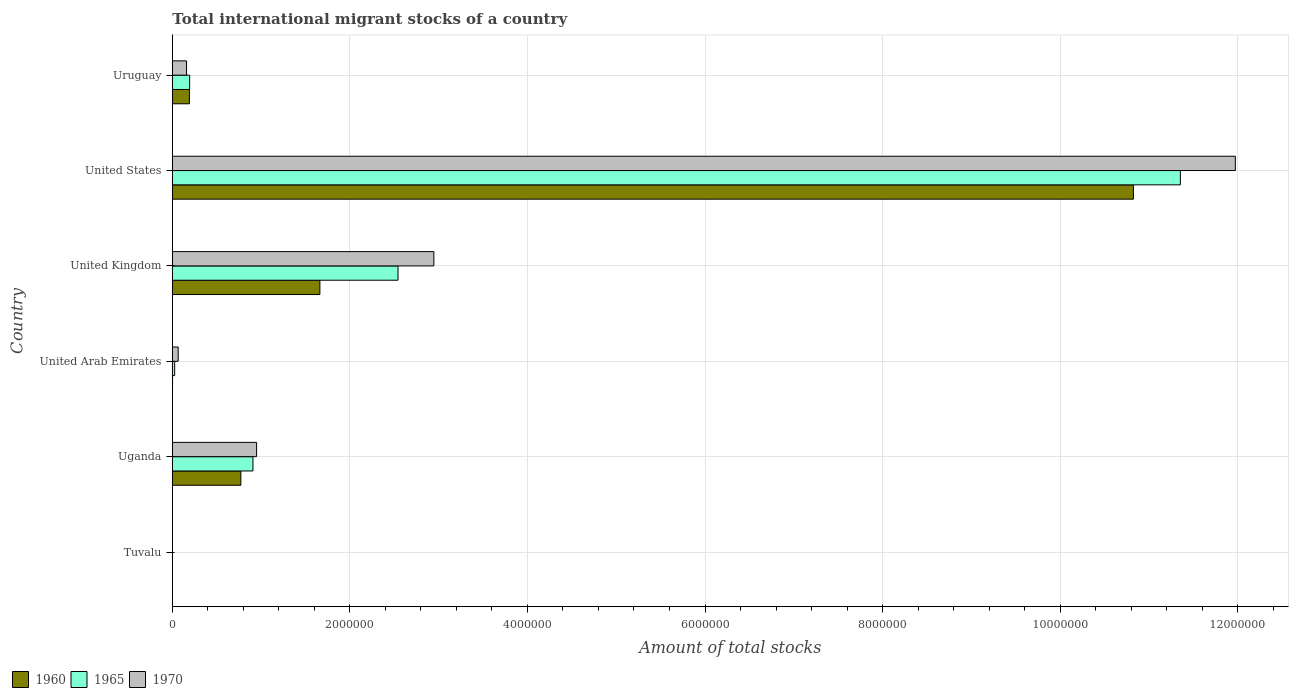How many different coloured bars are there?
Make the answer very short. 3. How many groups of bars are there?
Your answer should be compact. 6. Are the number of bars on each tick of the Y-axis equal?
Make the answer very short. Yes. In how many cases, is the number of bars for a given country not equal to the number of legend labels?
Provide a short and direct response. 0. What is the amount of total stocks in in 1970 in Uganda?
Give a very brief answer. 9.49e+05. Across all countries, what is the maximum amount of total stocks in in 1960?
Your answer should be very brief. 1.08e+07. Across all countries, what is the minimum amount of total stocks in in 1960?
Offer a terse response. 372. In which country was the amount of total stocks in in 1970 maximum?
Provide a short and direct response. United States. In which country was the amount of total stocks in in 1965 minimum?
Provide a short and direct response. Tuvalu. What is the total amount of total stocks in in 1970 in the graph?
Provide a short and direct response. 1.61e+07. What is the difference between the amount of total stocks in in 1960 in Tuvalu and that in United Arab Emirates?
Give a very brief answer. -1822. What is the difference between the amount of total stocks in in 1970 in United Kingdom and the amount of total stocks in in 1960 in United States?
Offer a terse response. -7.88e+06. What is the average amount of total stocks in in 1960 per country?
Offer a very short reply. 2.24e+06. What is the difference between the amount of total stocks in in 1970 and amount of total stocks in in 1960 in Uruguay?
Ensure brevity in your answer.  -3.22e+04. What is the ratio of the amount of total stocks in in 1965 in Uganda to that in United Kingdom?
Keep it short and to the point. 0.36. Is the difference between the amount of total stocks in in 1970 in United Arab Emirates and Uruguay greater than the difference between the amount of total stocks in in 1960 in United Arab Emirates and Uruguay?
Your answer should be compact. Yes. What is the difference between the highest and the second highest amount of total stocks in in 1960?
Provide a succinct answer. 9.16e+06. What is the difference between the highest and the lowest amount of total stocks in in 1965?
Your response must be concise. 1.14e+07. Is the sum of the amount of total stocks in in 1970 in Tuvalu and United Arab Emirates greater than the maximum amount of total stocks in in 1965 across all countries?
Provide a short and direct response. No. What does the 2nd bar from the top in United Kingdom represents?
Ensure brevity in your answer.  1965. What does the 3rd bar from the bottom in United States represents?
Provide a succinct answer. 1970. Is it the case that in every country, the sum of the amount of total stocks in in 1960 and amount of total stocks in in 1970 is greater than the amount of total stocks in in 1965?
Offer a terse response. Yes. How many bars are there?
Your answer should be compact. 18. Are the values on the major ticks of X-axis written in scientific E-notation?
Your answer should be compact. No. Does the graph contain any zero values?
Provide a succinct answer. No. Where does the legend appear in the graph?
Give a very brief answer. Bottom left. What is the title of the graph?
Ensure brevity in your answer.  Total international migrant stocks of a country. Does "1970" appear as one of the legend labels in the graph?
Give a very brief answer. Yes. What is the label or title of the X-axis?
Your answer should be very brief. Amount of total stocks. What is the Amount of total stocks in 1960 in Tuvalu?
Make the answer very short. 372. What is the Amount of total stocks in 1965 in Tuvalu?
Give a very brief answer. 363. What is the Amount of total stocks of 1970 in Tuvalu?
Ensure brevity in your answer.  355. What is the Amount of total stocks of 1960 in Uganda?
Make the answer very short. 7.72e+05. What is the Amount of total stocks of 1965 in Uganda?
Give a very brief answer. 9.08e+05. What is the Amount of total stocks of 1970 in Uganda?
Ensure brevity in your answer.  9.49e+05. What is the Amount of total stocks of 1960 in United Arab Emirates?
Your response must be concise. 2194. What is the Amount of total stocks of 1965 in United Arab Emirates?
Make the answer very short. 2.60e+04. What is the Amount of total stocks of 1970 in United Arab Emirates?
Provide a succinct answer. 6.58e+04. What is the Amount of total stocks of 1960 in United Kingdom?
Offer a very short reply. 1.66e+06. What is the Amount of total stocks of 1965 in United Kingdom?
Offer a terse response. 2.54e+06. What is the Amount of total stocks of 1970 in United Kingdom?
Ensure brevity in your answer.  2.95e+06. What is the Amount of total stocks in 1960 in United States?
Keep it short and to the point. 1.08e+07. What is the Amount of total stocks in 1965 in United States?
Give a very brief answer. 1.14e+07. What is the Amount of total stocks in 1970 in United States?
Your answer should be very brief. 1.20e+07. What is the Amount of total stocks in 1960 in Uruguay?
Keep it short and to the point. 1.92e+05. What is the Amount of total stocks of 1965 in Uruguay?
Keep it short and to the point. 1.95e+05. What is the Amount of total stocks of 1970 in Uruguay?
Your answer should be compact. 1.60e+05. Across all countries, what is the maximum Amount of total stocks in 1960?
Give a very brief answer. 1.08e+07. Across all countries, what is the maximum Amount of total stocks in 1965?
Offer a very short reply. 1.14e+07. Across all countries, what is the maximum Amount of total stocks of 1970?
Keep it short and to the point. 1.20e+07. Across all countries, what is the minimum Amount of total stocks of 1960?
Your response must be concise. 372. Across all countries, what is the minimum Amount of total stocks in 1965?
Keep it short and to the point. 363. Across all countries, what is the minimum Amount of total stocks of 1970?
Ensure brevity in your answer.  355. What is the total Amount of total stocks in 1960 in the graph?
Ensure brevity in your answer.  1.35e+07. What is the total Amount of total stocks in 1965 in the graph?
Keep it short and to the point. 1.50e+07. What is the total Amount of total stocks in 1970 in the graph?
Give a very brief answer. 1.61e+07. What is the difference between the Amount of total stocks of 1960 in Tuvalu and that in Uganda?
Your response must be concise. -7.71e+05. What is the difference between the Amount of total stocks of 1965 in Tuvalu and that in Uganda?
Offer a very short reply. -9.07e+05. What is the difference between the Amount of total stocks in 1970 in Tuvalu and that in Uganda?
Ensure brevity in your answer.  -9.49e+05. What is the difference between the Amount of total stocks in 1960 in Tuvalu and that in United Arab Emirates?
Offer a terse response. -1822. What is the difference between the Amount of total stocks in 1965 in Tuvalu and that in United Arab Emirates?
Provide a succinct answer. -2.56e+04. What is the difference between the Amount of total stocks in 1970 in Tuvalu and that in United Arab Emirates?
Offer a very short reply. -6.55e+04. What is the difference between the Amount of total stocks in 1960 in Tuvalu and that in United Kingdom?
Provide a short and direct response. -1.66e+06. What is the difference between the Amount of total stocks of 1965 in Tuvalu and that in United Kingdom?
Your response must be concise. -2.54e+06. What is the difference between the Amount of total stocks of 1970 in Tuvalu and that in United Kingdom?
Provide a short and direct response. -2.95e+06. What is the difference between the Amount of total stocks in 1960 in Tuvalu and that in United States?
Keep it short and to the point. -1.08e+07. What is the difference between the Amount of total stocks in 1965 in Tuvalu and that in United States?
Provide a short and direct response. -1.14e+07. What is the difference between the Amount of total stocks of 1970 in Tuvalu and that in United States?
Your answer should be compact. -1.20e+07. What is the difference between the Amount of total stocks of 1960 in Tuvalu and that in Uruguay?
Ensure brevity in your answer.  -1.92e+05. What is the difference between the Amount of total stocks in 1965 in Tuvalu and that in Uruguay?
Offer a very short reply. -1.95e+05. What is the difference between the Amount of total stocks of 1970 in Tuvalu and that in Uruguay?
Your answer should be very brief. -1.60e+05. What is the difference between the Amount of total stocks of 1960 in Uganda and that in United Arab Emirates?
Give a very brief answer. 7.70e+05. What is the difference between the Amount of total stocks of 1965 in Uganda and that in United Arab Emirates?
Your answer should be compact. 8.82e+05. What is the difference between the Amount of total stocks of 1970 in Uganda and that in United Arab Emirates?
Offer a terse response. 8.83e+05. What is the difference between the Amount of total stocks in 1960 in Uganda and that in United Kingdom?
Give a very brief answer. -8.90e+05. What is the difference between the Amount of total stocks in 1965 in Uganda and that in United Kingdom?
Ensure brevity in your answer.  -1.63e+06. What is the difference between the Amount of total stocks of 1970 in Uganda and that in United Kingdom?
Your response must be concise. -2.00e+06. What is the difference between the Amount of total stocks in 1960 in Uganda and that in United States?
Your answer should be very brief. -1.01e+07. What is the difference between the Amount of total stocks in 1965 in Uganda and that in United States?
Keep it short and to the point. -1.04e+07. What is the difference between the Amount of total stocks in 1970 in Uganda and that in United States?
Keep it short and to the point. -1.10e+07. What is the difference between the Amount of total stocks in 1960 in Uganda and that in Uruguay?
Provide a succinct answer. 5.80e+05. What is the difference between the Amount of total stocks of 1965 in Uganda and that in Uruguay?
Your answer should be compact. 7.13e+05. What is the difference between the Amount of total stocks of 1970 in Uganda and that in Uruguay?
Ensure brevity in your answer.  7.89e+05. What is the difference between the Amount of total stocks of 1960 in United Arab Emirates and that in United Kingdom?
Offer a terse response. -1.66e+06. What is the difference between the Amount of total stocks of 1965 in United Arab Emirates and that in United Kingdom?
Your response must be concise. -2.52e+06. What is the difference between the Amount of total stocks in 1970 in United Arab Emirates and that in United Kingdom?
Keep it short and to the point. -2.88e+06. What is the difference between the Amount of total stocks of 1960 in United Arab Emirates and that in United States?
Keep it short and to the point. -1.08e+07. What is the difference between the Amount of total stocks in 1965 in United Arab Emirates and that in United States?
Give a very brief answer. -1.13e+07. What is the difference between the Amount of total stocks of 1970 in United Arab Emirates and that in United States?
Your answer should be compact. -1.19e+07. What is the difference between the Amount of total stocks in 1960 in United Arab Emirates and that in Uruguay?
Give a very brief answer. -1.90e+05. What is the difference between the Amount of total stocks in 1965 in United Arab Emirates and that in Uruguay?
Your answer should be very brief. -1.69e+05. What is the difference between the Amount of total stocks of 1970 in United Arab Emirates and that in Uruguay?
Keep it short and to the point. -9.41e+04. What is the difference between the Amount of total stocks in 1960 in United Kingdom and that in United States?
Offer a very short reply. -9.16e+06. What is the difference between the Amount of total stocks in 1965 in United Kingdom and that in United States?
Your answer should be very brief. -8.81e+06. What is the difference between the Amount of total stocks in 1970 in United Kingdom and that in United States?
Provide a succinct answer. -9.03e+06. What is the difference between the Amount of total stocks in 1960 in United Kingdom and that in Uruguay?
Your answer should be compact. 1.47e+06. What is the difference between the Amount of total stocks of 1965 in United Kingdom and that in Uruguay?
Offer a terse response. 2.35e+06. What is the difference between the Amount of total stocks of 1970 in United Kingdom and that in Uruguay?
Ensure brevity in your answer.  2.79e+06. What is the difference between the Amount of total stocks of 1960 in United States and that in Uruguay?
Your answer should be compact. 1.06e+07. What is the difference between the Amount of total stocks in 1965 in United States and that in Uruguay?
Your response must be concise. 1.12e+07. What is the difference between the Amount of total stocks in 1970 in United States and that in Uruguay?
Your answer should be compact. 1.18e+07. What is the difference between the Amount of total stocks in 1960 in Tuvalu and the Amount of total stocks in 1965 in Uganda?
Give a very brief answer. -9.07e+05. What is the difference between the Amount of total stocks in 1960 in Tuvalu and the Amount of total stocks in 1970 in Uganda?
Your response must be concise. -9.49e+05. What is the difference between the Amount of total stocks of 1965 in Tuvalu and the Amount of total stocks of 1970 in Uganda?
Ensure brevity in your answer.  -9.49e+05. What is the difference between the Amount of total stocks in 1960 in Tuvalu and the Amount of total stocks in 1965 in United Arab Emirates?
Provide a short and direct response. -2.56e+04. What is the difference between the Amount of total stocks in 1960 in Tuvalu and the Amount of total stocks in 1970 in United Arab Emirates?
Your response must be concise. -6.55e+04. What is the difference between the Amount of total stocks of 1965 in Tuvalu and the Amount of total stocks of 1970 in United Arab Emirates?
Your response must be concise. -6.55e+04. What is the difference between the Amount of total stocks in 1960 in Tuvalu and the Amount of total stocks in 1965 in United Kingdom?
Your answer should be very brief. -2.54e+06. What is the difference between the Amount of total stocks of 1960 in Tuvalu and the Amount of total stocks of 1970 in United Kingdom?
Make the answer very short. -2.95e+06. What is the difference between the Amount of total stocks in 1965 in Tuvalu and the Amount of total stocks in 1970 in United Kingdom?
Offer a very short reply. -2.95e+06. What is the difference between the Amount of total stocks in 1960 in Tuvalu and the Amount of total stocks in 1965 in United States?
Give a very brief answer. -1.14e+07. What is the difference between the Amount of total stocks of 1960 in Tuvalu and the Amount of total stocks of 1970 in United States?
Offer a terse response. -1.20e+07. What is the difference between the Amount of total stocks of 1965 in Tuvalu and the Amount of total stocks of 1970 in United States?
Your response must be concise. -1.20e+07. What is the difference between the Amount of total stocks in 1960 in Tuvalu and the Amount of total stocks in 1965 in Uruguay?
Provide a succinct answer. -1.95e+05. What is the difference between the Amount of total stocks in 1960 in Tuvalu and the Amount of total stocks in 1970 in Uruguay?
Give a very brief answer. -1.60e+05. What is the difference between the Amount of total stocks in 1965 in Tuvalu and the Amount of total stocks in 1970 in Uruguay?
Give a very brief answer. -1.60e+05. What is the difference between the Amount of total stocks in 1960 in Uganda and the Amount of total stocks in 1965 in United Arab Emirates?
Provide a short and direct response. 7.46e+05. What is the difference between the Amount of total stocks in 1960 in Uganda and the Amount of total stocks in 1970 in United Arab Emirates?
Give a very brief answer. 7.06e+05. What is the difference between the Amount of total stocks in 1965 in Uganda and the Amount of total stocks in 1970 in United Arab Emirates?
Your response must be concise. 8.42e+05. What is the difference between the Amount of total stocks in 1960 in Uganda and the Amount of total stocks in 1965 in United Kingdom?
Offer a very short reply. -1.77e+06. What is the difference between the Amount of total stocks in 1960 in Uganda and the Amount of total stocks in 1970 in United Kingdom?
Offer a terse response. -2.17e+06. What is the difference between the Amount of total stocks in 1965 in Uganda and the Amount of total stocks in 1970 in United Kingdom?
Your answer should be very brief. -2.04e+06. What is the difference between the Amount of total stocks in 1960 in Uganda and the Amount of total stocks in 1965 in United States?
Provide a succinct answer. -1.06e+07. What is the difference between the Amount of total stocks in 1960 in Uganda and the Amount of total stocks in 1970 in United States?
Provide a short and direct response. -1.12e+07. What is the difference between the Amount of total stocks in 1965 in Uganda and the Amount of total stocks in 1970 in United States?
Your answer should be very brief. -1.11e+07. What is the difference between the Amount of total stocks in 1960 in Uganda and the Amount of total stocks in 1965 in Uruguay?
Your answer should be compact. 5.77e+05. What is the difference between the Amount of total stocks in 1960 in Uganda and the Amount of total stocks in 1970 in Uruguay?
Keep it short and to the point. 6.12e+05. What is the difference between the Amount of total stocks of 1965 in Uganda and the Amount of total stocks of 1970 in Uruguay?
Ensure brevity in your answer.  7.48e+05. What is the difference between the Amount of total stocks of 1960 in United Arab Emirates and the Amount of total stocks of 1965 in United Kingdom?
Give a very brief answer. -2.54e+06. What is the difference between the Amount of total stocks of 1960 in United Arab Emirates and the Amount of total stocks of 1970 in United Kingdom?
Provide a succinct answer. -2.94e+06. What is the difference between the Amount of total stocks in 1965 in United Arab Emirates and the Amount of total stocks in 1970 in United Kingdom?
Give a very brief answer. -2.92e+06. What is the difference between the Amount of total stocks of 1960 in United Arab Emirates and the Amount of total stocks of 1965 in United States?
Your response must be concise. -1.14e+07. What is the difference between the Amount of total stocks in 1960 in United Arab Emirates and the Amount of total stocks in 1970 in United States?
Your answer should be very brief. -1.20e+07. What is the difference between the Amount of total stocks of 1965 in United Arab Emirates and the Amount of total stocks of 1970 in United States?
Make the answer very short. -1.19e+07. What is the difference between the Amount of total stocks in 1960 in United Arab Emirates and the Amount of total stocks in 1965 in Uruguay?
Ensure brevity in your answer.  -1.93e+05. What is the difference between the Amount of total stocks in 1960 in United Arab Emirates and the Amount of total stocks in 1970 in Uruguay?
Provide a short and direct response. -1.58e+05. What is the difference between the Amount of total stocks of 1965 in United Arab Emirates and the Amount of total stocks of 1970 in Uruguay?
Make the answer very short. -1.34e+05. What is the difference between the Amount of total stocks of 1960 in United Kingdom and the Amount of total stocks of 1965 in United States?
Provide a succinct answer. -9.69e+06. What is the difference between the Amount of total stocks of 1960 in United Kingdom and the Amount of total stocks of 1970 in United States?
Offer a terse response. -1.03e+07. What is the difference between the Amount of total stocks of 1965 in United Kingdom and the Amount of total stocks of 1970 in United States?
Keep it short and to the point. -9.43e+06. What is the difference between the Amount of total stocks of 1960 in United Kingdom and the Amount of total stocks of 1965 in Uruguay?
Your answer should be compact. 1.47e+06. What is the difference between the Amount of total stocks in 1960 in United Kingdom and the Amount of total stocks in 1970 in Uruguay?
Make the answer very short. 1.50e+06. What is the difference between the Amount of total stocks of 1965 in United Kingdom and the Amount of total stocks of 1970 in Uruguay?
Your response must be concise. 2.38e+06. What is the difference between the Amount of total stocks of 1960 in United States and the Amount of total stocks of 1965 in Uruguay?
Keep it short and to the point. 1.06e+07. What is the difference between the Amount of total stocks in 1960 in United States and the Amount of total stocks in 1970 in Uruguay?
Keep it short and to the point. 1.07e+07. What is the difference between the Amount of total stocks of 1965 in United States and the Amount of total stocks of 1970 in Uruguay?
Provide a succinct answer. 1.12e+07. What is the average Amount of total stocks of 1960 per country?
Ensure brevity in your answer.  2.24e+06. What is the average Amount of total stocks in 1965 per country?
Offer a terse response. 2.50e+06. What is the average Amount of total stocks of 1970 per country?
Keep it short and to the point. 2.68e+06. What is the difference between the Amount of total stocks in 1960 and Amount of total stocks in 1970 in Tuvalu?
Offer a very short reply. 17. What is the difference between the Amount of total stocks in 1960 and Amount of total stocks in 1965 in Uganda?
Offer a terse response. -1.36e+05. What is the difference between the Amount of total stocks of 1960 and Amount of total stocks of 1970 in Uganda?
Ensure brevity in your answer.  -1.77e+05. What is the difference between the Amount of total stocks in 1965 and Amount of total stocks in 1970 in Uganda?
Provide a short and direct response. -4.12e+04. What is the difference between the Amount of total stocks of 1960 and Amount of total stocks of 1965 in United Arab Emirates?
Offer a very short reply. -2.38e+04. What is the difference between the Amount of total stocks of 1960 and Amount of total stocks of 1970 in United Arab Emirates?
Your answer should be compact. -6.36e+04. What is the difference between the Amount of total stocks of 1965 and Amount of total stocks of 1970 in United Arab Emirates?
Make the answer very short. -3.98e+04. What is the difference between the Amount of total stocks in 1960 and Amount of total stocks in 1965 in United Kingdom?
Make the answer very short. -8.80e+05. What is the difference between the Amount of total stocks in 1960 and Amount of total stocks in 1970 in United Kingdom?
Ensure brevity in your answer.  -1.28e+06. What is the difference between the Amount of total stocks of 1965 and Amount of total stocks of 1970 in United Kingdom?
Make the answer very short. -4.04e+05. What is the difference between the Amount of total stocks in 1960 and Amount of total stocks in 1965 in United States?
Provide a succinct answer. -5.29e+05. What is the difference between the Amount of total stocks in 1960 and Amount of total stocks in 1970 in United States?
Offer a very short reply. -1.15e+06. What is the difference between the Amount of total stocks in 1965 and Amount of total stocks in 1970 in United States?
Your answer should be compact. -6.19e+05. What is the difference between the Amount of total stocks in 1960 and Amount of total stocks in 1965 in Uruguay?
Give a very brief answer. -2864. What is the difference between the Amount of total stocks of 1960 and Amount of total stocks of 1970 in Uruguay?
Provide a succinct answer. 3.22e+04. What is the difference between the Amount of total stocks in 1965 and Amount of total stocks in 1970 in Uruguay?
Your response must be concise. 3.51e+04. What is the ratio of the Amount of total stocks in 1960 in Tuvalu to that in Uganda?
Your answer should be very brief. 0. What is the ratio of the Amount of total stocks in 1965 in Tuvalu to that in Uganda?
Ensure brevity in your answer.  0. What is the ratio of the Amount of total stocks in 1970 in Tuvalu to that in Uganda?
Give a very brief answer. 0. What is the ratio of the Amount of total stocks in 1960 in Tuvalu to that in United Arab Emirates?
Your response must be concise. 0.17. What is the ratio of the Amount of total stocks in 1965 in Tuvalu to that in United Arab Emirates?
Your answer should be compact. 0.01. What is the ratio of the Amount of total stocks in 1970 in Tuvalu to that in United Arab Emirates?
Provide a short and direct response. 0.01. What is the ratio of the Amount of total stocks in 1960 in Tuvalu to that in United Kingdom?
Make the answer very short. 0. What is the ratio of the Amount of total stocks of 1965 in Tuvalu to that in United Kingdom?
Your answer should be compact. 0. What is the ratio of the Amount of total stocks of 1970 in Tuvalu to that in United Kingdom?
Offer a terse response. 0. What is the ratio of the Amount of total stocks of 1960 in Tuvalu to that in United States?
Provide a short and direct response. 0. What is the ratio of the Amount of total stocks in 1965 in Tuvalu to that in United States?
Your answer should be very brief. 0. What is the ratio of the Amount of total stocks in 1970 in Tuvalu to that in United States?
Keep it short and to the point. 0. What is the ratio of the Amount of total stocks in 1960 in Tuvalu to that in Uruguay?
Your response must be concise. 0. What is the ratio of the Amount of total stocks in 1965 in Tuvalu to that in Uruguay?
Provide a succinct answer. 0. What is the ratio of the Amount of total stocks of 1970 in Tuvalu to that in Uruguay?
Your answer should be compact. 0. What is the ratio of the Amount of total stocks in 1960 in Uganda to that in United Arab Emirates?
Your answer should be compact. 351.75. What is the ratio of the Amount of total stocks of 1965 in Uganda to that in United Arab Emirates?
Provide a succinct answer. 34.94. What is the ratio of the Amount of total stocks in 1970 in Uganda to that in United Arab Emirates?
Give a very brief answer. 14.41. What is the ratio of the Amount of total stocks in 1960 in Uganda to that in United Kingdom?
Provide a succinct answer. 0.46. What is the ratio of the Amount of total stocks in 1965 in Uganda to that in United Kingdom?
Provide a succinct answer. 0.36. What is the ratio of the Amount of total stocks of 1970 in Uganda to that in United Kingdom?
Your answer should be compact. 0.32. What is the ratio of the Amount of total stocks of 1960 in Uganda to that in United States?
Give a very brief answer. 0.07. What is the ratio of the Amount of total stocks in 1965 in Uganda to that in United States?
Keep it short and to the point. 0.08. What is the ratio of the Amount of total stocks in 1970 in Uganda to that in United States?
Ensure brevity in your answer.  0.08. What is the ratio of the Amount of total stocks of 1960 in Uganda to that in Uruguay?
Your response must be concise. 4.02. What is the ratio of the Amount of total stocks in 1965 in Uganda to that in Uruguay?
Your answer should be very brief. 4.65. What is the ratio of the Amount of total stocks of 1970 in Uganda to that in Uruguay?
Offer a terse response. 5.93. What is the ratio of the Amount of total stocks of 1960 in United Arab Emirates to that in United Kingdom?
Give a very brief answer. 0. What is the ratio of the Amount of total stocks in 1965 in United Arab Emirates to that in United Kingdom?
Your response must be concise. 0.01. What is the ratio of the Amount of total stocks in 1970 in United Arab Emirates to that in United Kingdom?
Provide a short and direct response. 0.02. What is the ratio of the Amount of total stocks in 1965 in United Arab Emirates to that in United States?
Provide a short and direct response. 0. What is the ratio of the Amount of total stocks in 1970 in United Arab Emirates to that in United States?
Make the answer very short. 0.01. What is the ratio of the Amount of total stocks of 1960 in United Arab Emirates to that in Uruguay?
Offer a terse response. 0.01. What is the ratio of the Amount of total stocks of 1965 in United Arab Emirates to that in Uruguay?
Keep it short and to the point. 0.13. What is the ratio of the Amount of total stocks in 1970 in United Arab Emirates to that in Uruguay?
Your answer should be compact. 0.41. What is the ratio of the Amount of total stocks of 1960 in United Kingdom to that in United States?
Your response must be concise. 0.15. What is the ratio of the Amount of total stocks of 1965 in United Kingdom to that in United States?
Provide a succinct answer. 0.22. What is the ratio of the Amount of total stocks in 1970 in United Kingdom to that in United States?
Offer a terse response. 0.25. What is the ratio of the Amount of total stocks in 1960 in United Kingdom to that in Uruguay?
Your answer should be compact. 8.65. What is the ratio of the Amount of total stocks of 1965 in United Kingdom to that in Uruguay?
Provide a succinct answer. 13.03. What is the ratio of the Amount of total stocks in 1970 in United Kingdom to that in Uruguay?
Give a very brief answer. 18.42. What is the ratio of the Amount of total stocks in 1960 in United States to that in Uruguay?
Offer a very short reply. 56.34. What is the ratio of the Amount of total stocks of 1965 in United States to that in Uruguay?
Keep it short and to the point. 58.22. What is the ratio of the Amount of total stocks in 1970 in United States to that in Uruguay?
Provide a succinct answer. 74.85. What is the difference between the highest and the second highest Amount of total stocks in 1960?
Offer a terse response. 9.16e+06. What is the difference between the highest and the second highest Amount of total stocks of 1965?
Keep it short and to the point. 8.81e+06. What is the difference between the highest and the second highest Amount of total stocks of 1970?
Provide a short and direct response. 9.03e+06. What is the difference between the highest and the lowest Amount of total stocks in 1960?
Offer a very short reply. 1.08e+07. What is the difference between the highest and the lowest Amount of total stocks of 1965?
Ensure brevity in your answer.  1.14e+07. What is the difference between the highest and the lowest Amount of total stocks in 1970?
Give a very brief answer. 1.20e+07. 